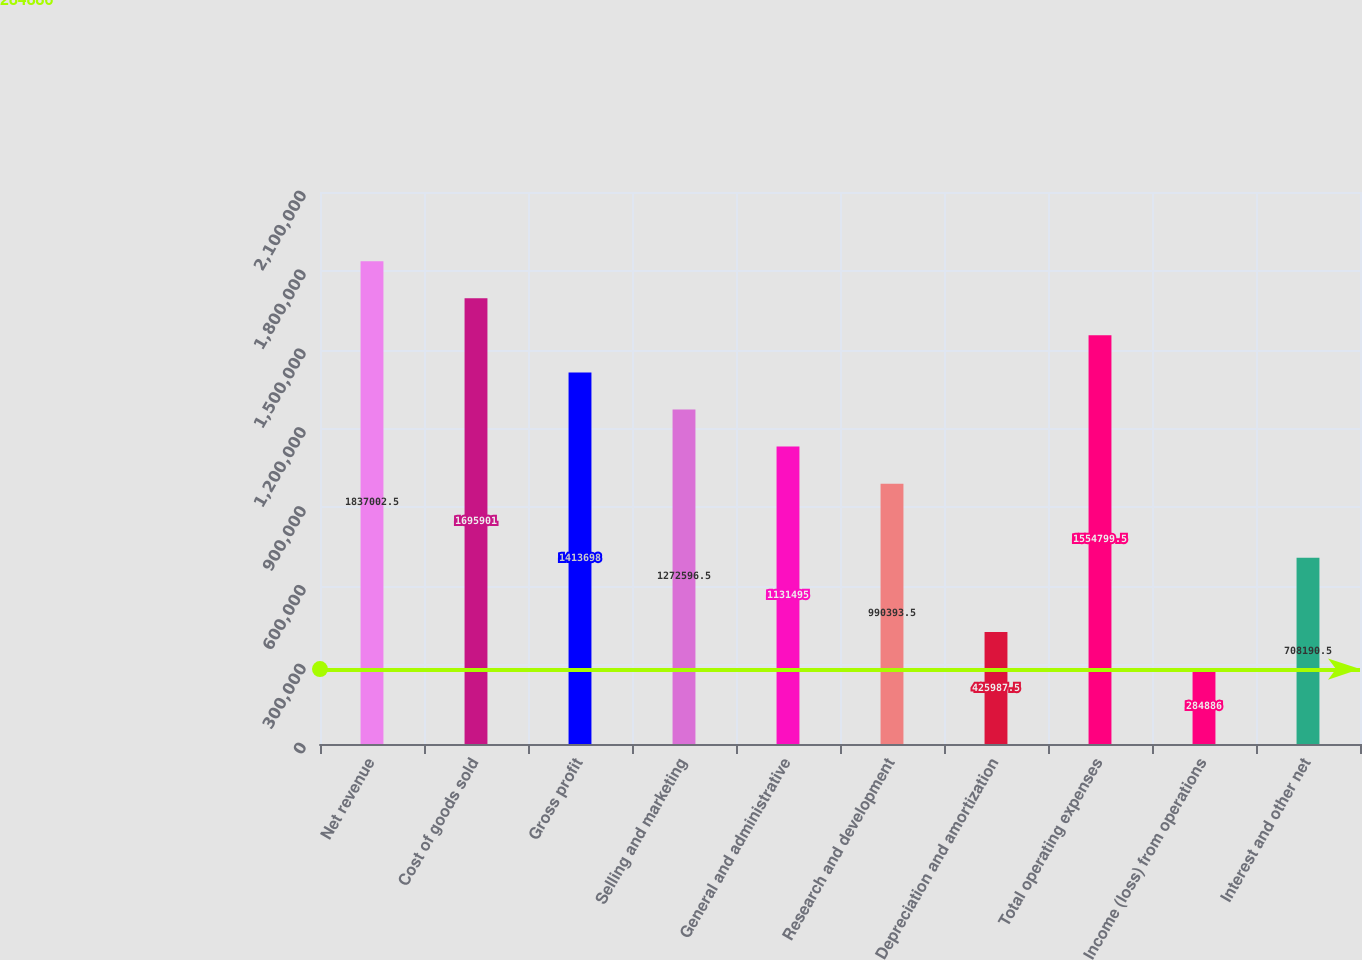Convert chart to OTSL. <chart><loc_0><loc_0><loc_500><loc_500><bar_chart><fcel>Net revenue<fcel>Cost of goods sold<fcel>Gross profit<fcel>Selling and marketing<fcel>General and administrative<fcel>Research and development<fcel>Depreciation and amortization<fcel>Total operating expenses<fcel>Income (loss) from operations<fcel>Interest and other net<nl><fcel>1.837e+06<fcel>1.6959e+06<fcel>1.4137e+06<fcel>1.2726e+06<fcel>1.1315e+06<fcel>990394<fcel>425988<fcel>1.5548e+06<fcel>284886<fcel>708190<nl></chart> 